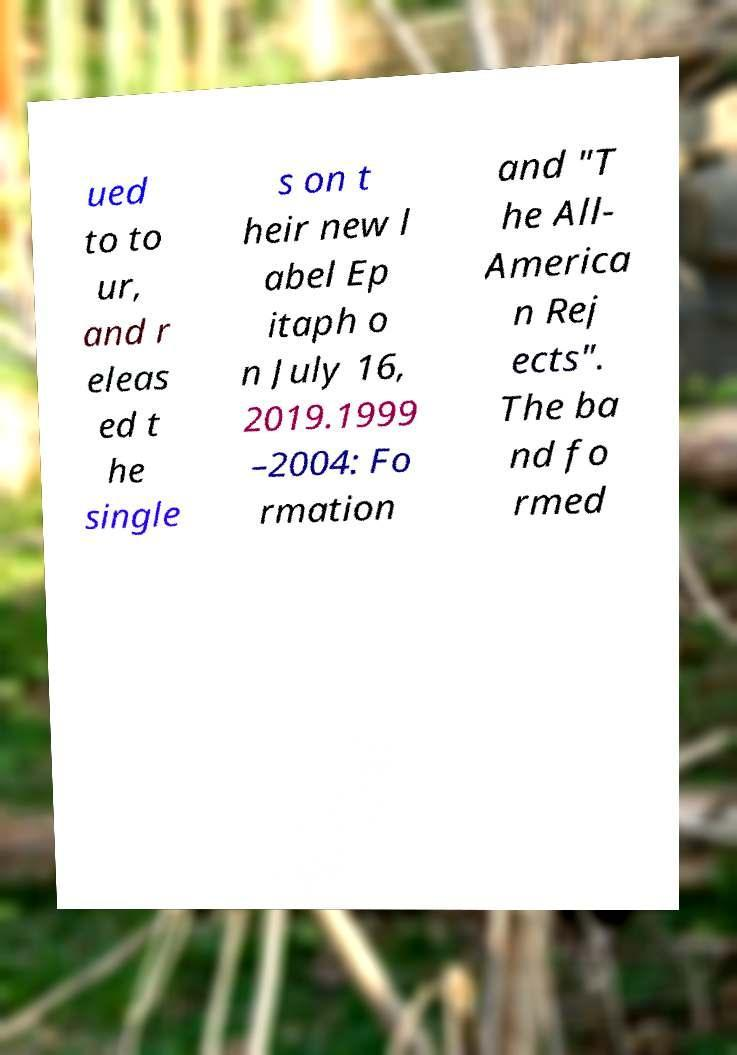Could you assist in decoding the text presented in this image and type it out clearly? ued to to ur, and r eleas ed t he single s on t heir new l abel Ep itaph o n July 16, 2019.1999 –2004: Fo rmation and "T he All- America n Rej ects". The ba nd fo rmed 